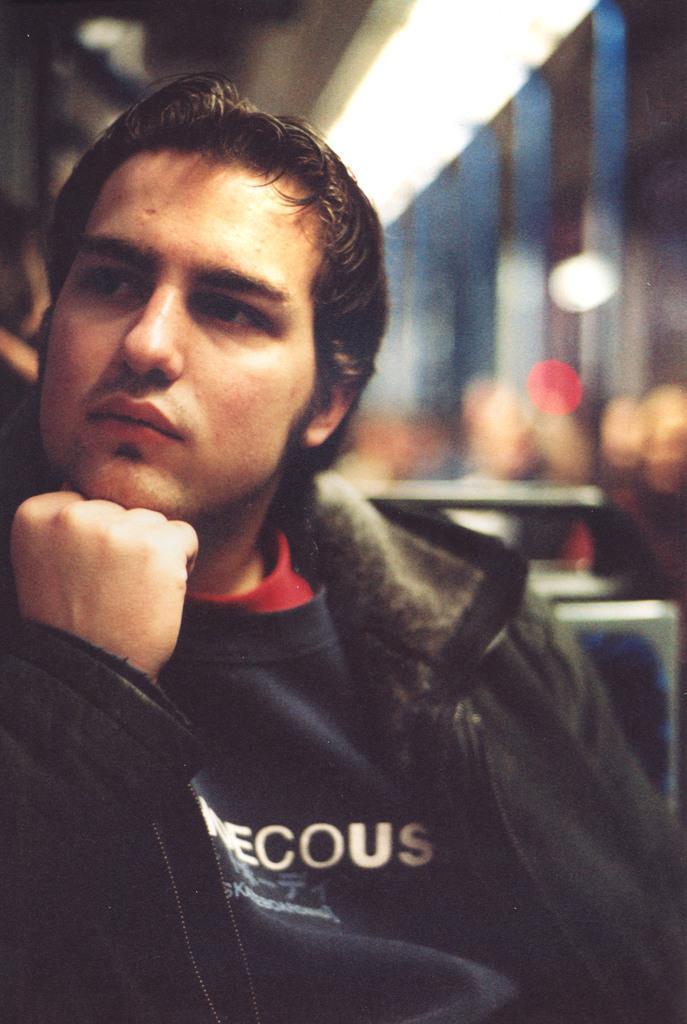How would you summarize this image in a sentence or two? In this image there is a man sitting on chair, in the background it is blurred. 